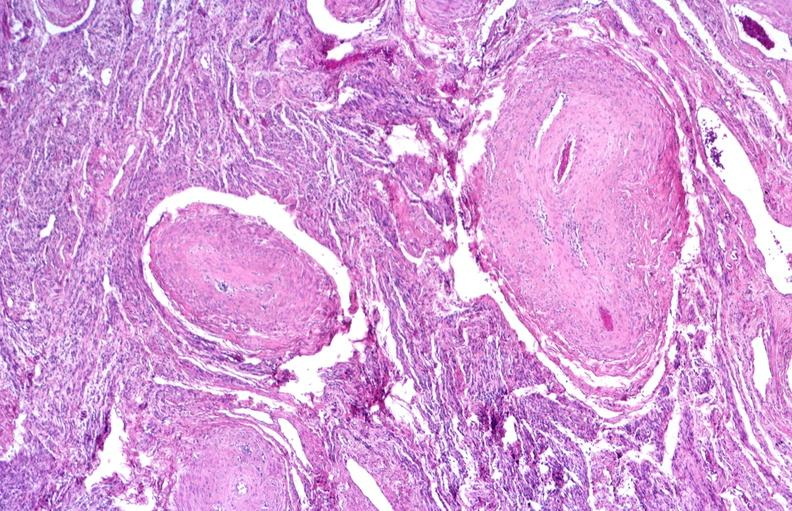does atrophy show kidney, polyarteritis nodosa?
Answer the question using a single word or phrase. No 